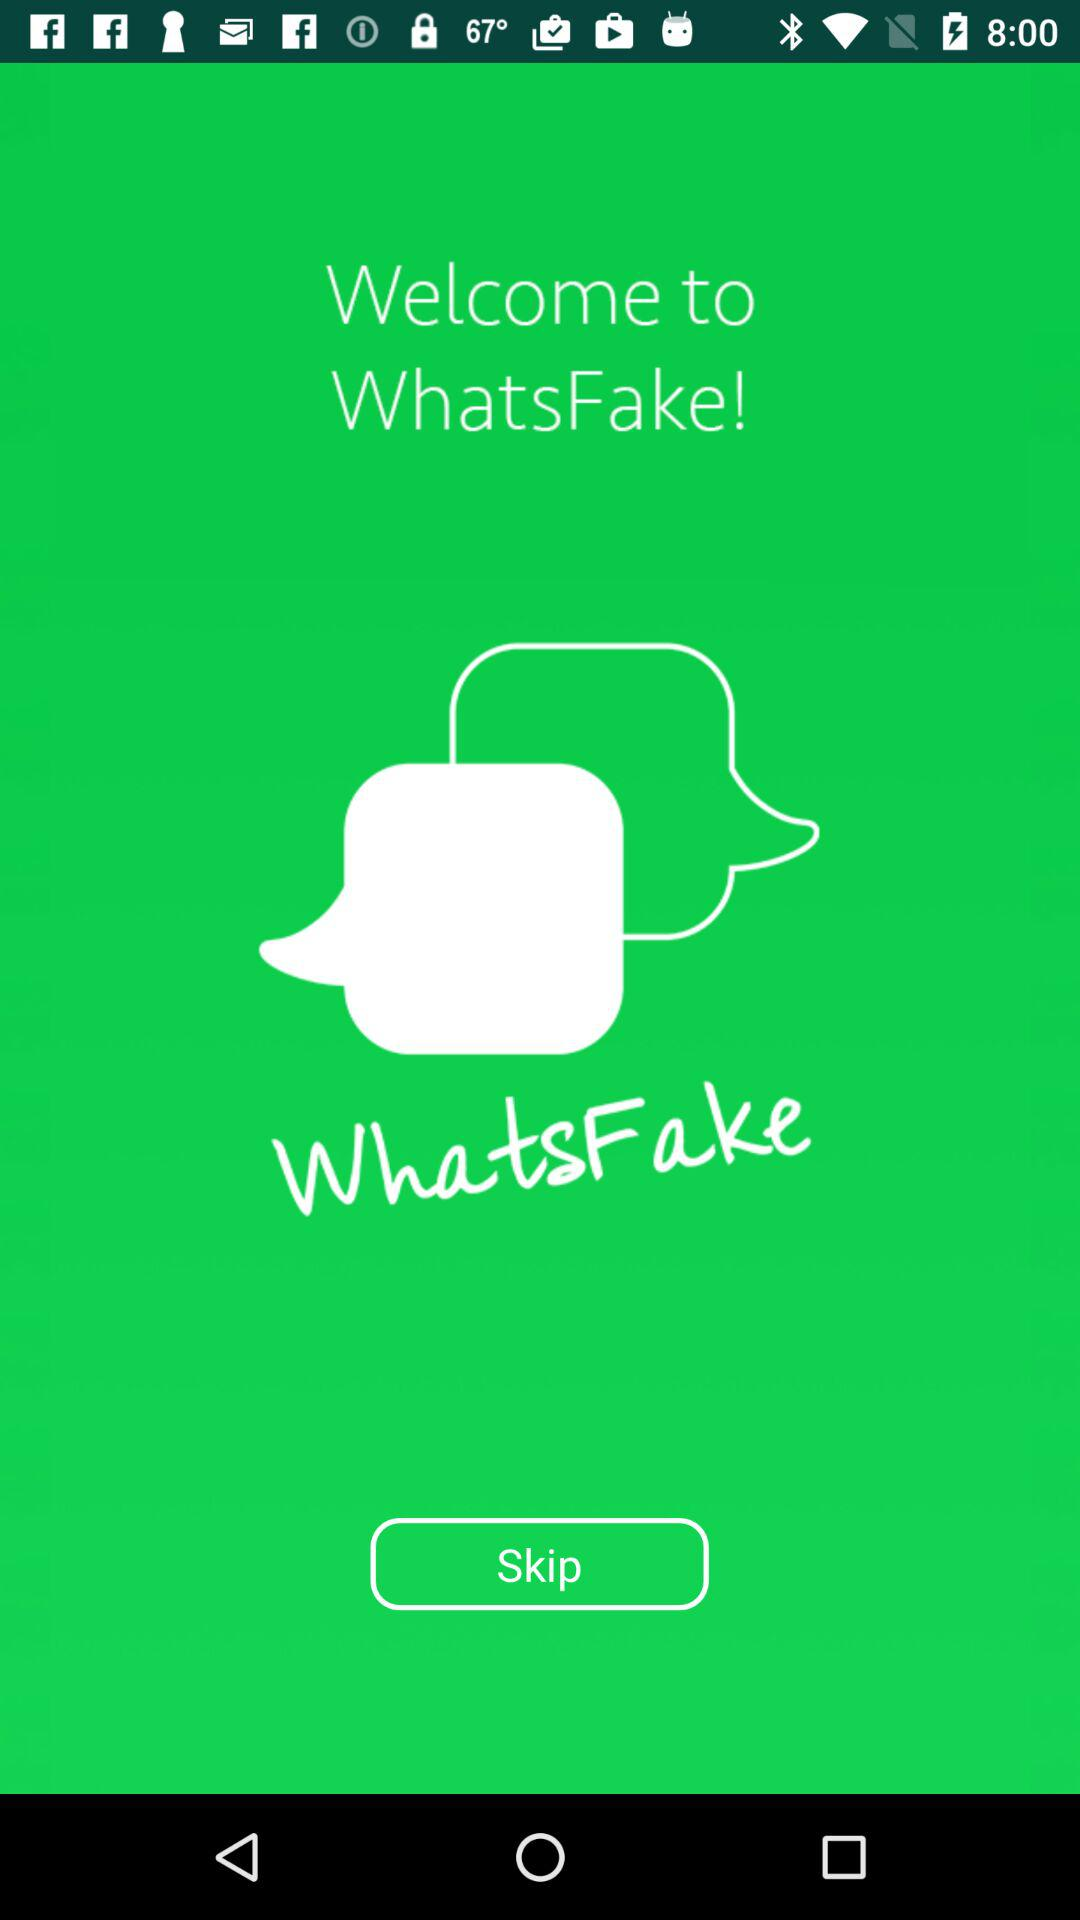What is the name of the application? The name of the application is "WhatsFake!". 